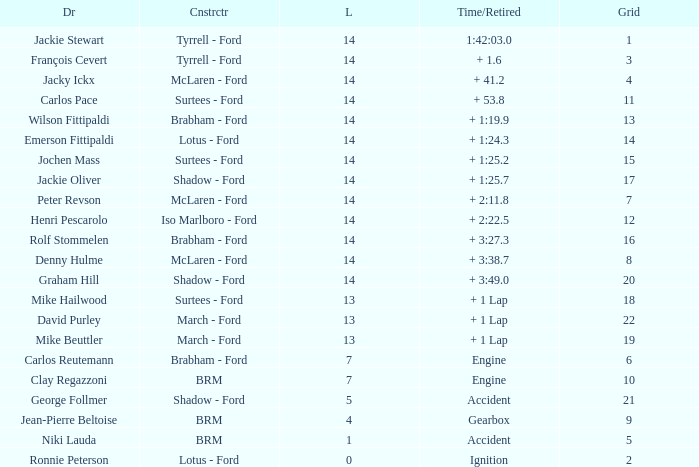What grad has a Time/Retired of + 1:24.3? 14.0. 